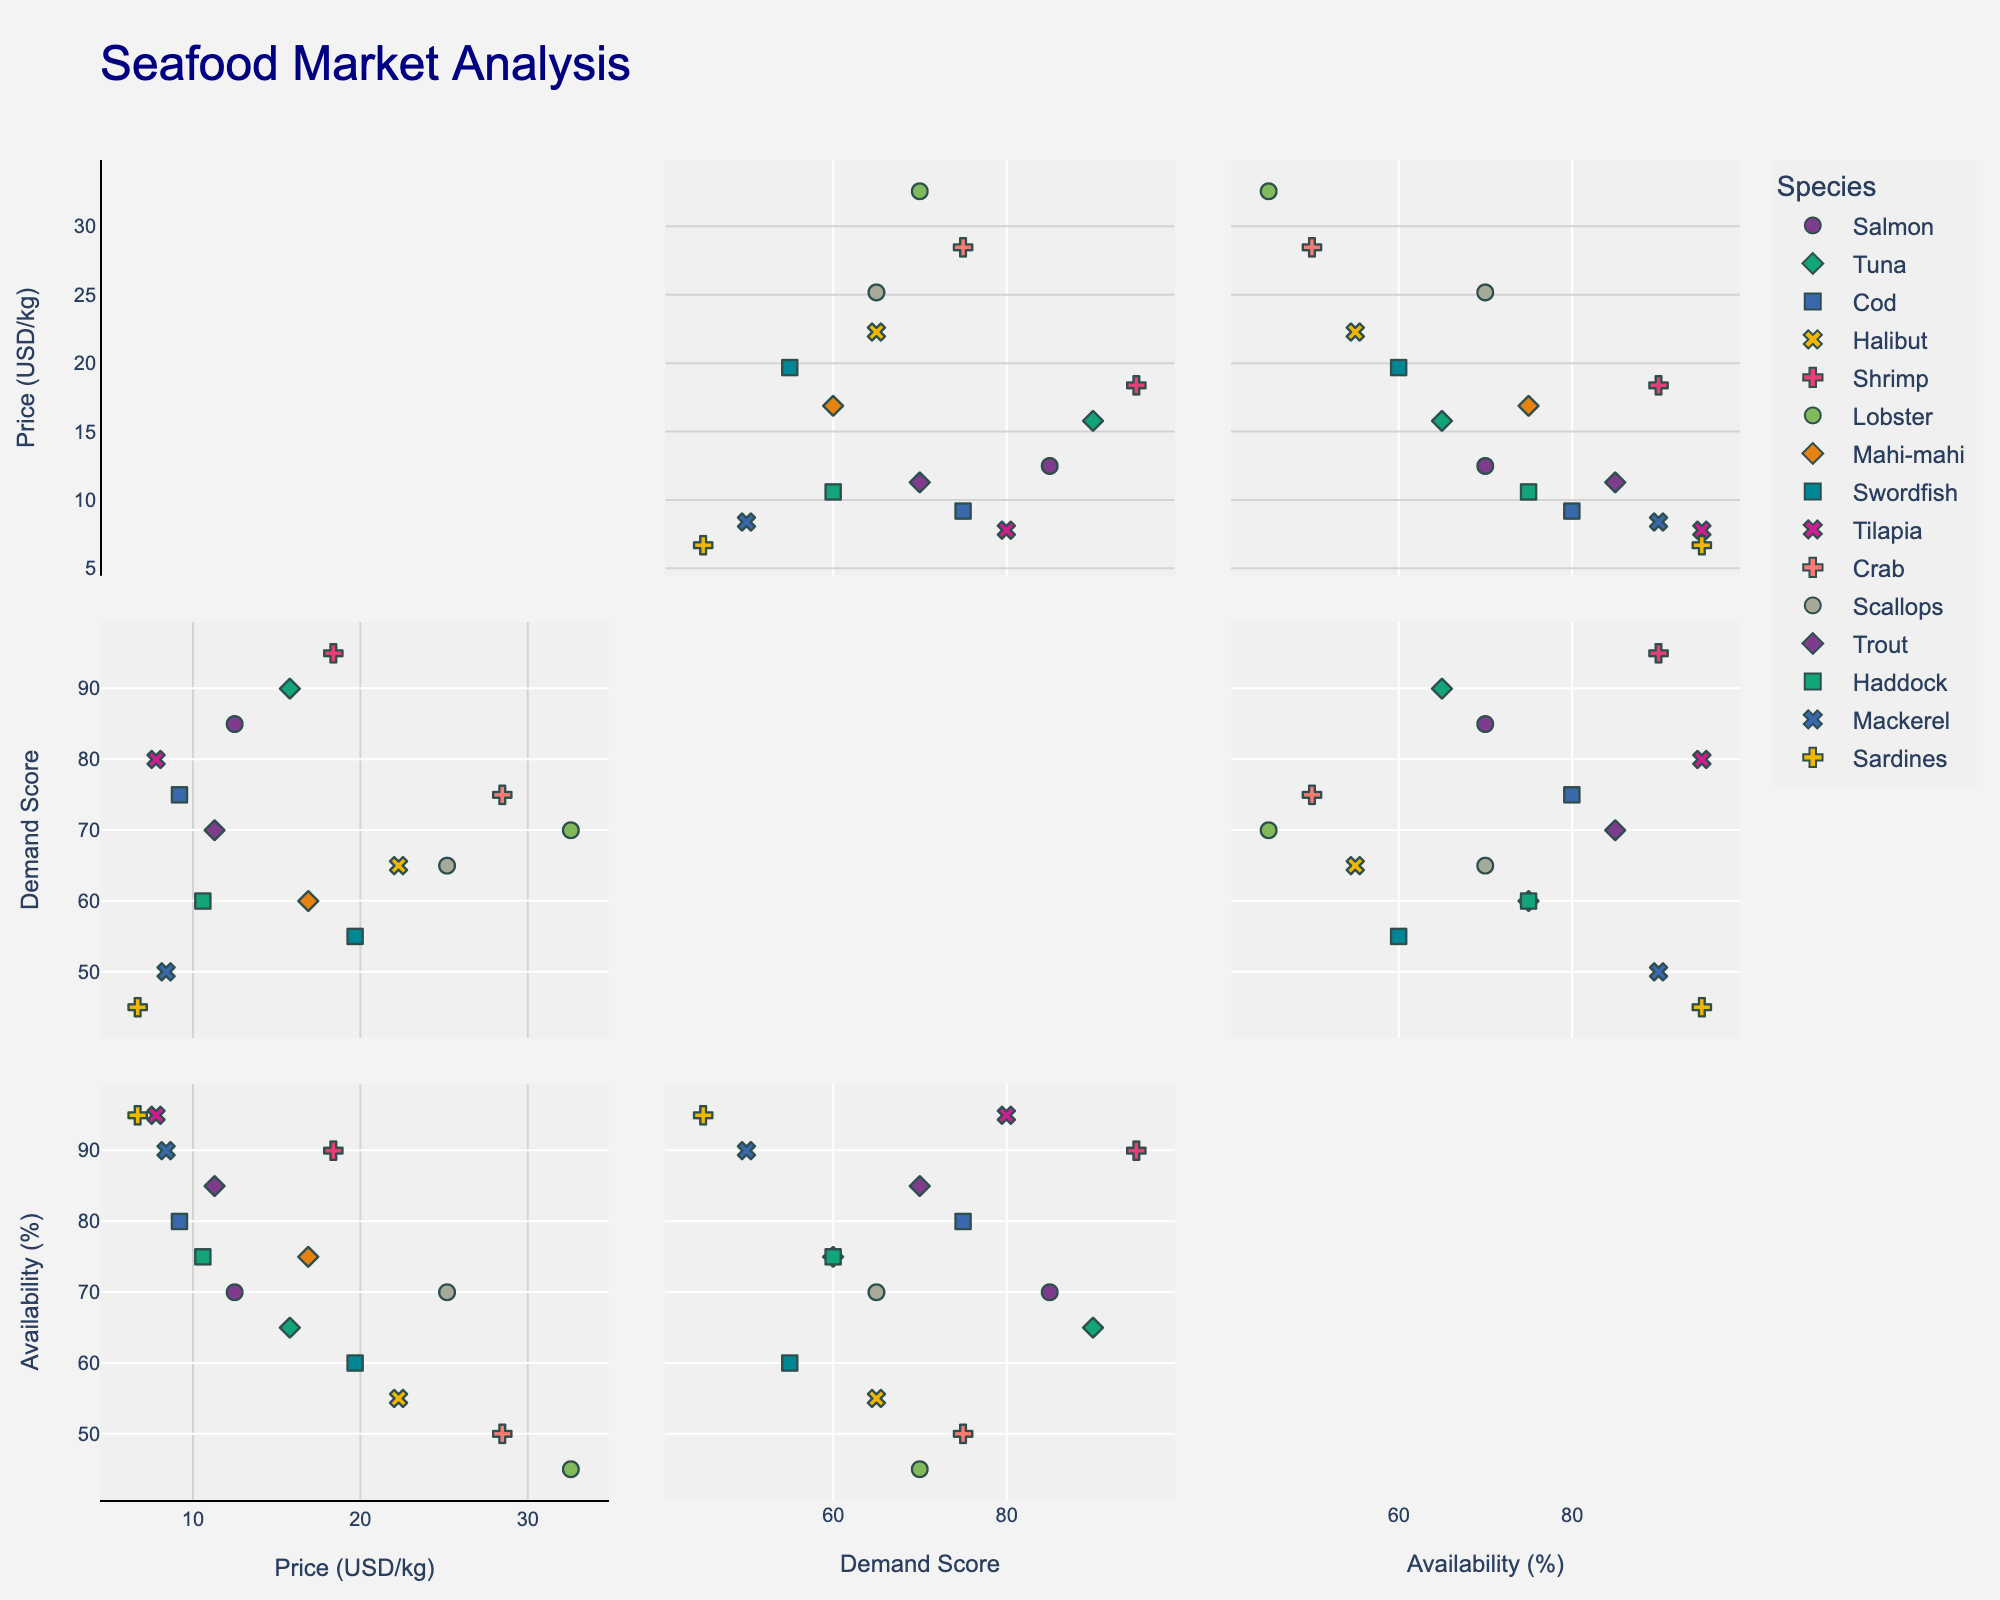What is the title of the plot? The title of the plot is usually displayed at the top and provides an overview of what the plot represents. In this case, it gives an idea of the purpose of the plot. The title shown is "Seafood Market Analysis".
Answer: Seafood Market Analysis Which species has the highest market price per kg? The data points can be identified by their colors and symbols, and the market price per kg can be determined by looking at the "Price (USD/kg)" axis. The species with the highest value along this axis is Lobster.
Answer: Lobster How many species have a consumer demand score higher than 80? Check the "Demand Score" axis and count the number of data points positioned above the 80 mark. Five species fall into this category: Salmon, Tuna, Shrimp, Tilapia, and Crab.
Answer: 5 Is there a species that has a low seasonal availability percentage but high demand? To determine this, look for data points with high demand scores (above 80) and low availability percentages (below 60). Lobster fits this description with a demand score of 70 and an availability percentage of 45.
Answer: Yes, Lobster Do any species have a market price per kg less than 10 USD and a consumer demand score above 70? Identify data points where the price is less than 10 USD and the demand score is above 70. Cod and Tilapia meet these criteria.
Answer: Cod and Tilapia Which species have both high market prices and high demand scores? Look for data points in the upper right quadrant of the scatterplot matrix (high prices and high demand). Species like Tuna, Shrimp, and Crab fall into this category.
Answer: Tuna, Shrimp, Crab What is the relationship between seasonal availability and market price? Examine the trend or pattern of data points in the scatterplot comparing these two variables. Generally, there is no strong correlation visible; the points do not display a clear upward or downward trend.
Answer: Weak/No strong correlation Does the species with the highest demand score also have the highest market price? Compare the highest points on the "Demand Score" axis with the highest points on the "Price (USD/kg)" axis. The highest demand score is for Shrimp with 95, but the highest market price is for Lobster at 32.60 USD/kg.
Answer: No Which species have an availability percentage greater than or equal to 90%? Locate data points at or above the 90% mark on the "Availability (%)" axis. Shrimp, Mackerel, and Sardines have availability percentages of 90%, 90%, and 95% respectively.
Answer: Shrimp, Mackerel, Sardines 